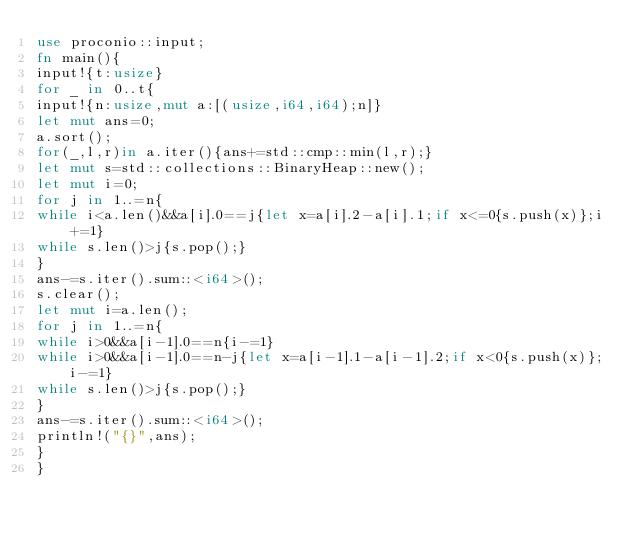Convert code to text. <code><loc_0><loc_0><loc_500><loc_500><_Rust_>use proconio::input;
fn main(){
input!{t:usize}
for _ in 0..t{
input!{n:usize,mut a:[(usize,i64,i64);n]}
let mut ans=0;
a.sort();
for(_,l,r)in a.iter(){ans+=std::cmp::min(l,r);}
let mut s=std::collections::BinaryHeap::new();
let mut i=0;
for j in 1..=n{
while i<a.len()&&a[i].0==j{let x=a[i].2-a[i].1;if x<=0{s.push(x)};i+=1}
while s.len()>j{s.pop();}
}
ans-=s.iter().sum::<i64>();
s.clear();
let mut i=a.len();
for j in 1..=n{
while i>0&&a[i-1].0==n{i-=1}
while i>0&&a[i-1].0==n-j{let x=a[i-1].1-a[i-1].2;if x<0{s.push(x)};i-=1}
while s.len()>j{s.pop();}
}
ans-=s.iter().sum::<i64>();
println!("{}",ans);
}
}</code> 